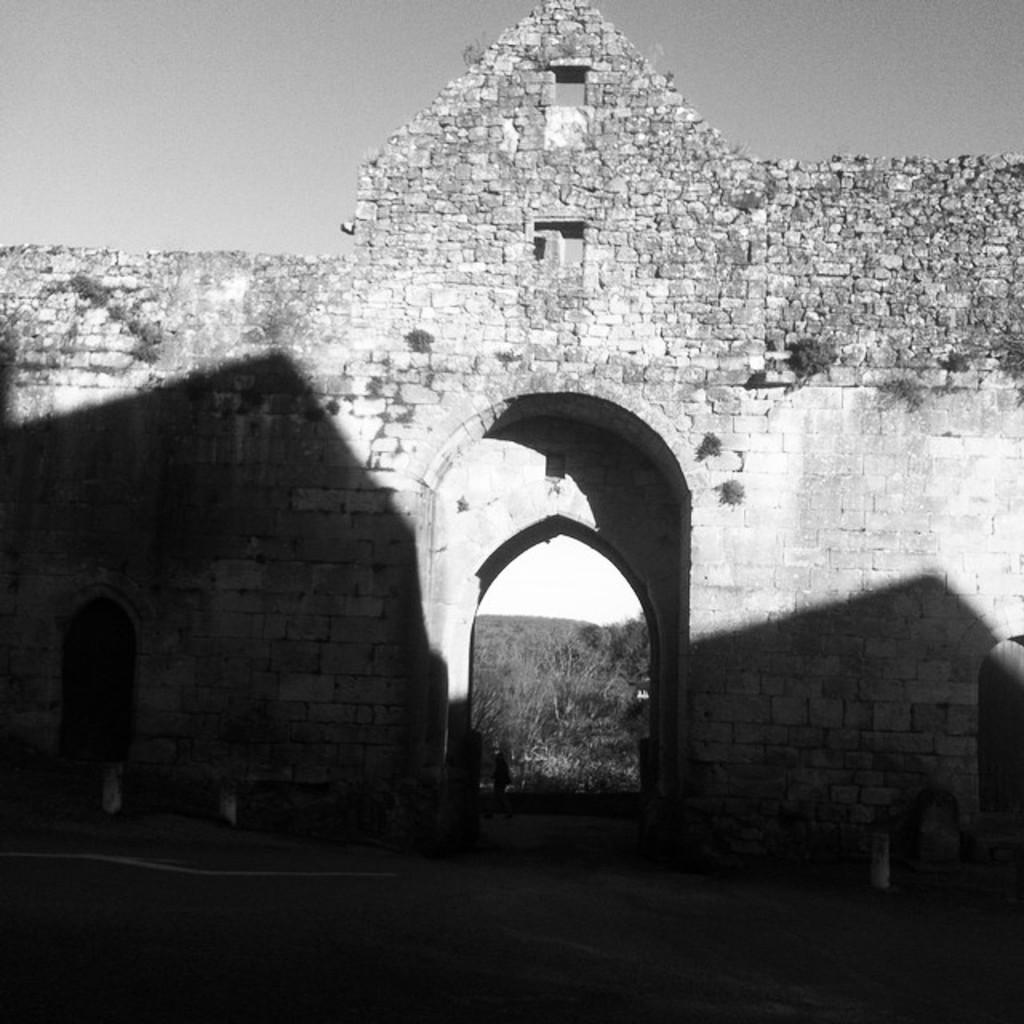What type of structure can be seen in the image? There is a wall in the image. What type of natural vegetation is present in the image? There are trees in the image. How is the image presented in terms of color? The photography is in black and white. What type of discussion is taking place in the image? There is no discussion present in the image; it features a wall and trees. What type of oil can be seen dripping from the trees in the image? There is no oil present in the image; it features a wall and trees. What type of queen is depicted on the wall in the image? There is no queen depicted on the wall in the image; it features a wall and trees. 